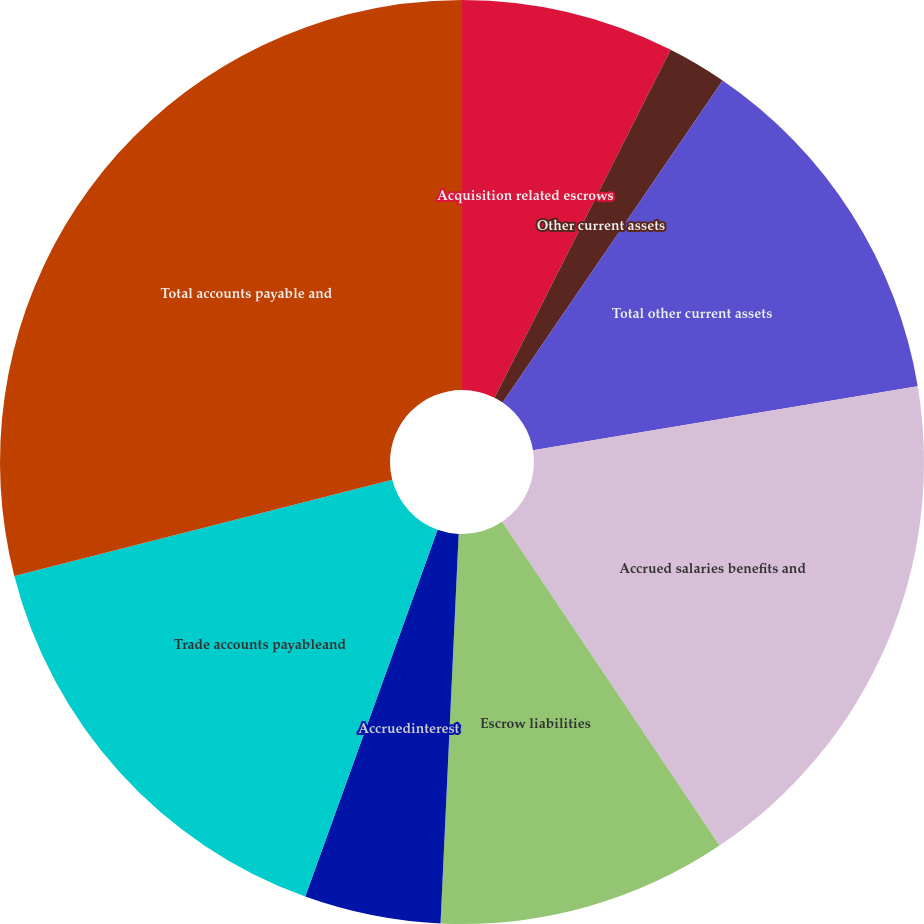Convert chart. <chart><loc_0><loc_0><loc_500><loc_500><pie_chart><fcel>Acquisition related escrows<fcel>Other current assets<fcel>Total other current assets<fcel>Accrued salaries benefits and<fcel>Escrow liabilities<fcel>Accruedinterest<fcel>Trade accounts payableand<fcel>Total accounts payable and<nl><fcel>7.46%<fcel>2.08%<fcel>12.84%<fcel>18.21%<fcel>10.15%<fcel>4.77%<fcel>15.52%<fcel>28.97%<nl></chart> 